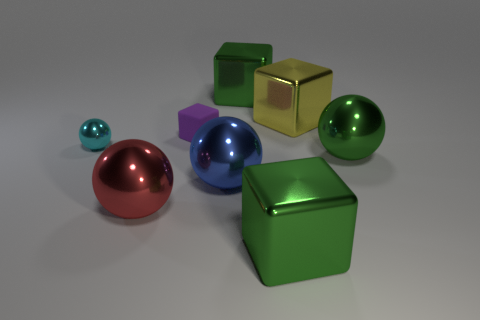Is there any other thing that has the same material as the small block?
Keep it short and to the point. No. Is the cyan thing the same shape as the purple thing?
Provide a succinct answer. No. What size is the green cube that is behind the large metal cube in front of the big blue shiny thing?
Your answer should be compact. Large. There is a matte object that is the same shape as the large yellow metal object; what color is it?
Your answer should be compact. Purple. How many other rubber blocks are the same color as the tiny matte block?
Keep it short and to the point. 0. The matte cube is what size?
Provide a succinct answer. Small. Is the size of the purple rubber thing the same as the yellow cube?
Make the answer very short. No. There is a metal thing that is both behind the red shiny object and on the left side of the purple rubber object; what color is it?
Make the answer very short. Cyan. What number of red objects have the same material as the big blue object?
Provide a short and direct response. 1. How many small cyan matte blocks are there?
Provide a short and direct response. 0. 